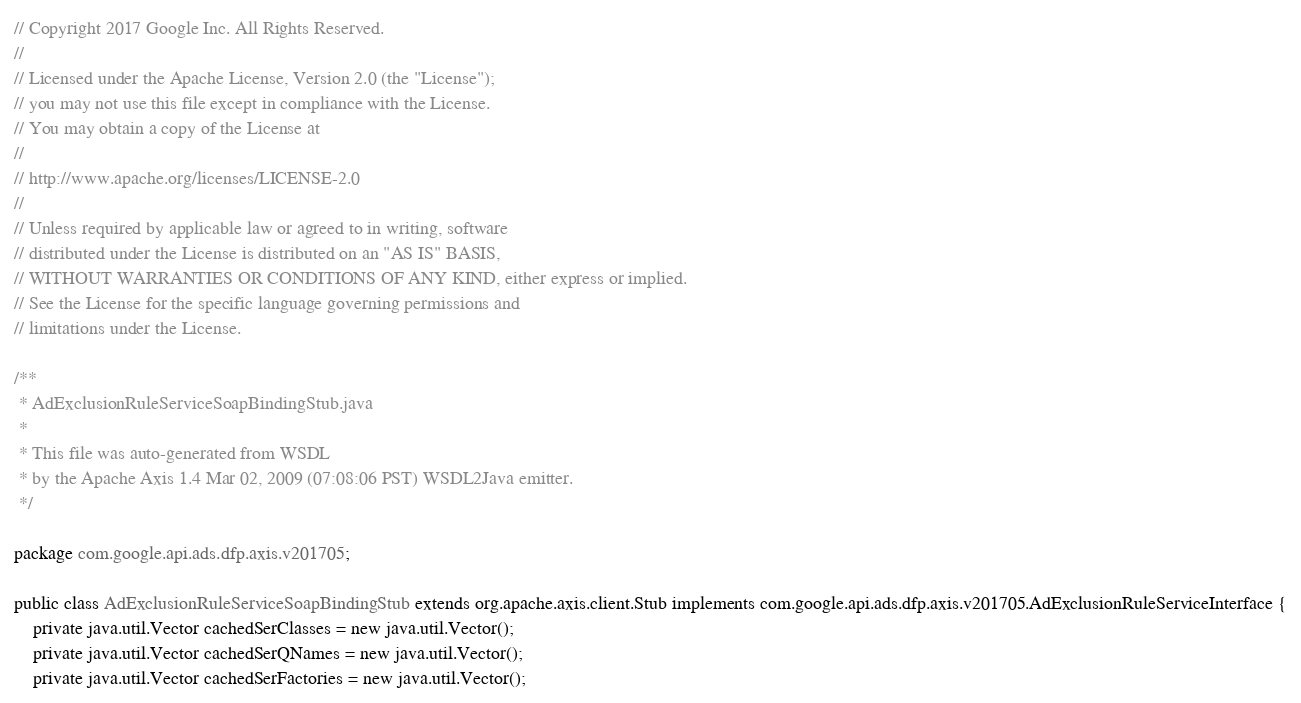<code> <loc_0><loc_0><loc_500><loc_500><_Java_>// Copyright 2017 Google Inc. All Rights Reserved.
//
// Licensed under the Apache License, Version 2.0 (the "License");
// you may not use this file except in compliance with the License.
// You may obtain a copy of the License at
//
// http://www.apache.org/licenses/LICENSE-2.0
//
// Unless required by applicable law or agreed to in writing, software
// distributed under the License is distributed on an "AS IS" BASIS,
// WITHOUT WARRANTIES OR CONDITIONS OF ANY KIND, either express or implied.
// See the License for the specific language governing permissions and
// limitations under the License.

/**
 * AdExclusionRuleServiceSoapBindingStub.java
 *
 * This file was auto-generated from WSDL
 * by the Apache Axis 1.4 Mar 02, 2009 (07:08:06 PST) WSDL2Java emitter.
 */

package com.google.api.ads.dfp.axis.v201705;

public class AdExclusionRuleServiceSoapBindingStub extends org.apache.axis.client.Stub implements com.google.api.ads.dfp.axis.v201705.AdExclusionRuleServiceInterface {
    private java.util.Vector cachedSerClasses = new java.util.Vector();
    private java.util.Vector cachedSerQNames = new java.util.Vector();
    private java.util.Vector cachedSerFactories = new java.util.Vector();</code> 